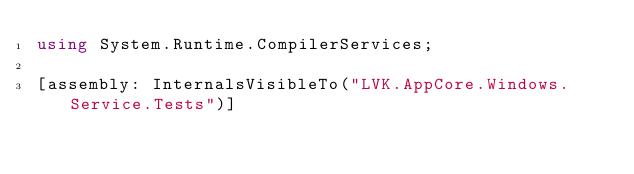<code> <loc_0><loc_0><loc_500><loc_500><_C#_>using System.Runtime.CompilerServices;

[assembly: InternalsVisibleTo("LVK.AppCore.Windows.Service.Tests")]</code> 